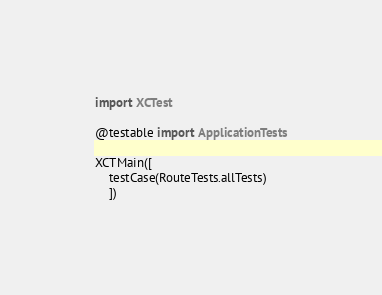<code> <loc_0><loc_0><loc_500><loc_500><_Swift_>import XCTest

@testable import ApplicationTests

XCTMain([
    testCase(RouteTests.allTests)
    ])
</code> 